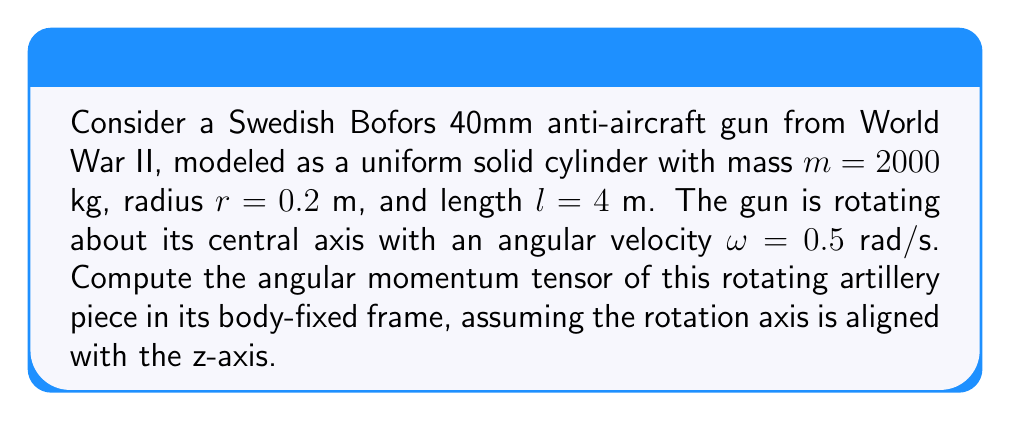Could you help me with this problem? To solve this problem, we'll follow these steps:

1) First, recall that for a rotating rigid body, the angular momentum tensor $\mathbf{L}$ is given by:

   $$\mathbf{L} = \mathbf{I} \cdot \boldsymbol{\omega}$$

   where $\mathbf{I}$ is the moment of inertia tensor and $\boldsymbol{\omega}$ is the angular velocity vector.

2) For a uniform solid cylinder rotating about its central axis (z-axis), the moment of inertia tensor in the body-fixed frame is:

   $$\mathbf{I} = \begin{pmatrix}
   I_{xx} & 0 & 0 \\
   0 & I_{yy} & 0 \\
   0 & 0 & I_{zz}
   \end{pmatrix}$$

   where $I_{xx} = I_{yy} = \frac{1}{12}m(3r^2 + l^2)$ and $I_{zz} = \frac{1}{2}mr^2$.

3) Calculate $I_{xx}$ and $I_{zz}$:
   
   $I_{xx} = I_{yy} = \frac{1}{12} \cdot 2000 \cdot (3 \cdot 0.2^2 + 4^2) = 2680$ kg·m²
   
   $I_{zz} = \frac{1}{2} \cdot 2000 \cdot 0.2^2 = 40$ kg·m²

4) The angular velocity vector in the body-fixed frame is:

   $$\boldsymbol{\omega} = \begin{pmatrix}
   0 \\ 0 \\ 0.5
   \end{pmatrix}$$ rad/s

5) Now we can compute the angular momentum tensor:

   $$\mathbf{L} = \mathbf{I} \cdot \boldsymbol{\omega} = \begin{pmatrix}
   2680 & 0 & 0 \\
   0 & 2680 & 0 \\
   0 & 0 & 40
   \end{pmatrix} \cdot \begin{pmatrix}
   0 \\ 0 \\ 0.5
   \end{pmatrix} = \begin{pmatrix}
   0 \\ 0 \\ 20
   \end{pmatrix}$$ kg·m²/s

Therefore, the angular momentum tensor in the body-fixed frame is:

$$\mathbf{L} = \begin{pmatrix}
0 \\ 0 \\ 20
\end{pmatrix}$$ kg·m²/s
Answer: $$\mathbf{L} = \begin{pmatrix} 0 \\ 0 \\ 20 \end{pmatrix}$$ kg·m²/s 